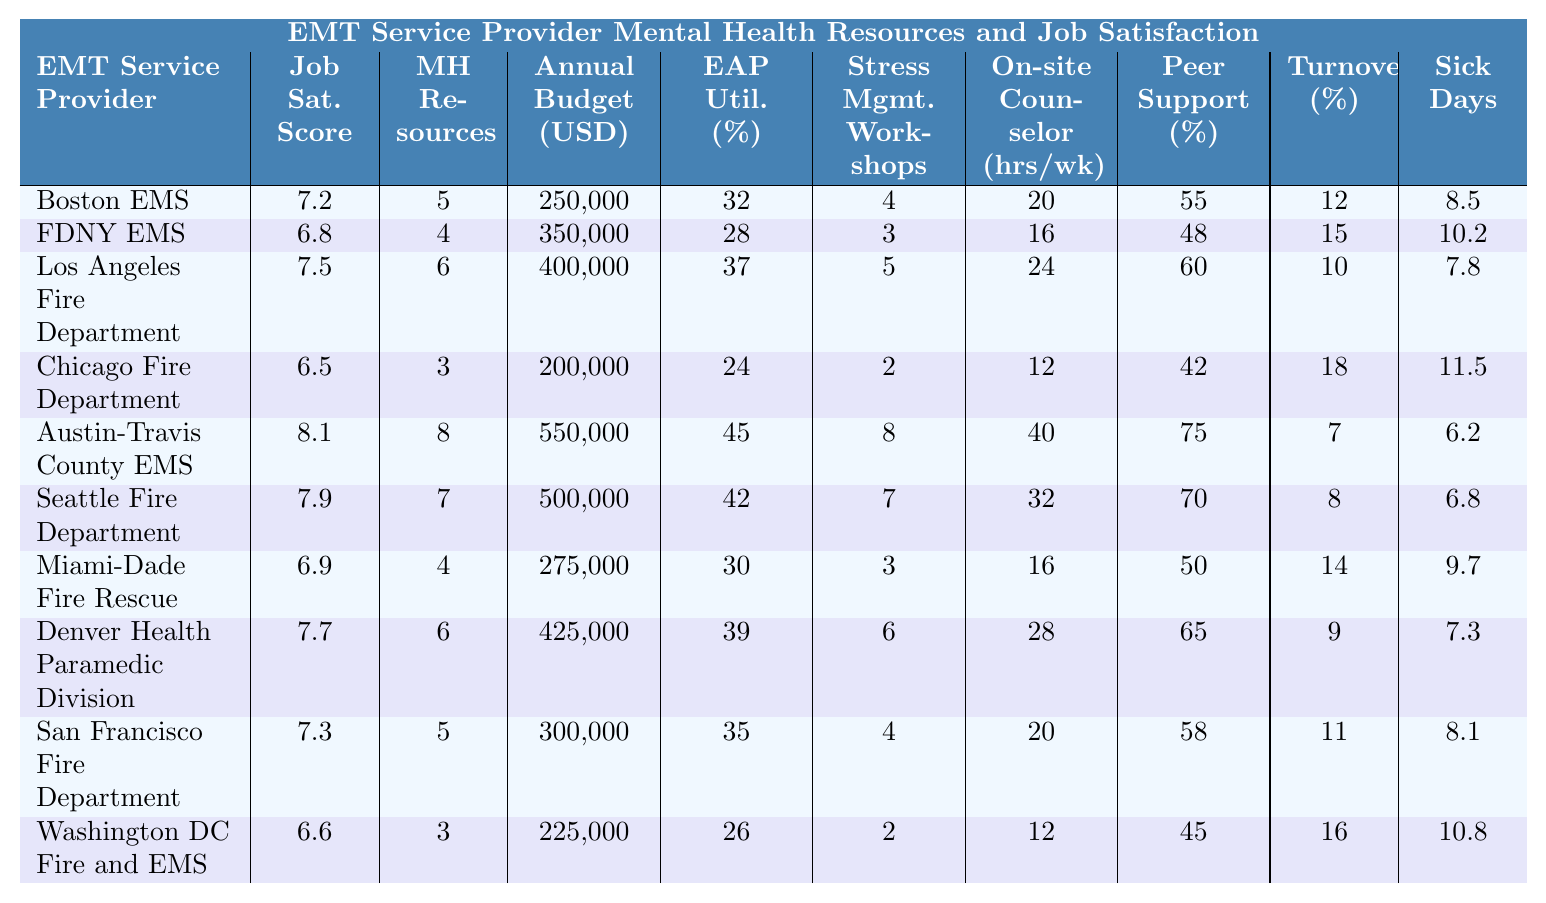What is the job satisfaction score of Austin-Travis County EMS? By looking at the table, we see the row for Austin-Travis County EMS shows a Job Satisfaction Score of 8.1.
Answer: 8.1 Which EMT service provider has the highest annual budget for mental health resources? Reviewing the table, the highest annual budget for mental health resources is 550,000, which belongs to Austin-Travis County EMS.
Answer: Austin-Travis County EMS What is the average job satisfaction score for all the EMT service providers mentioned? To calculate the average, we sum the job satisfaction scores (7.2 + 6.8 + 7.5 + 6.5 + 8.1 + 7.9 + 6.9 + 7.7 + 7.3 + 6.6 = 78.5) and divide by the total count of providers (10), resulting in 78.5 / 10 = 7.85.
Answer: 7.85 Which EMT service provider has the lowest percentage of Employee Assistance Program utilization? By checking the table, FDNY EMS has the lowest percentage of EAP utilization at 28%.
Answer: FDNY EMS Is there a correlation between mental health resources available and job satisfaction score? To analyze this, we observe that Austin-Travis County EMS has both the highest job satisfaction score (8.1) and the highest mental health resources available (8). This pattern continues where higher resources often correlate with higher satisfaction, suggesting a positive correlation overall.
Answer: Yes What is the difference in job satisfaction score between Miami-Dade Fire Rescue and Washington DC Fire and EMS? The job satisfaction score for Miami-Dade Fire Rescue is 6.9 while for Washington DC Fire EMS it is 6.6. The difference is calculated as 6.9 - 6.6 = 0.3.
Answer: 0.3 What is the average number of sick days taken per EMT annually across all service providers? Adding up the sick days taken (8.5 + 10.2 + 7.8 + 11.5 + 6.2 + 6.8 + 9.7 + 7.3 + 8.1 + 10.8 = 78.0) and dividing by 10 provides an average of 78.0 / 10 = 7.8.
Answer: 7.8 Which EMT service provider has the highest utilization rate of the Employee Assistance Program? Looking at the table, Austin-Travis County EMS has the highest EAP utilization at 45%.
Answer: Austin-Travis County EMS Determine whether any service provider has both a job satisfaction score above 7.5 and a turnover rate below 10%. Analyzing the table, only Austin-Travis County EMS achieves both criteria with a job satisfaction score of 8.1 and a turnover rate of 7%. This confirms its adherence to the criteria.
Answer: Yes What is the total number of stress management workshops held per year by all EMT service providers combined? Summing the individual workshops (4 + 3 + 5 + 2 + 8 + 7 + 3 + 6 + 4 + 2 = 40), we find that there are a total of 40 workshops held annually.
Answer: 40 